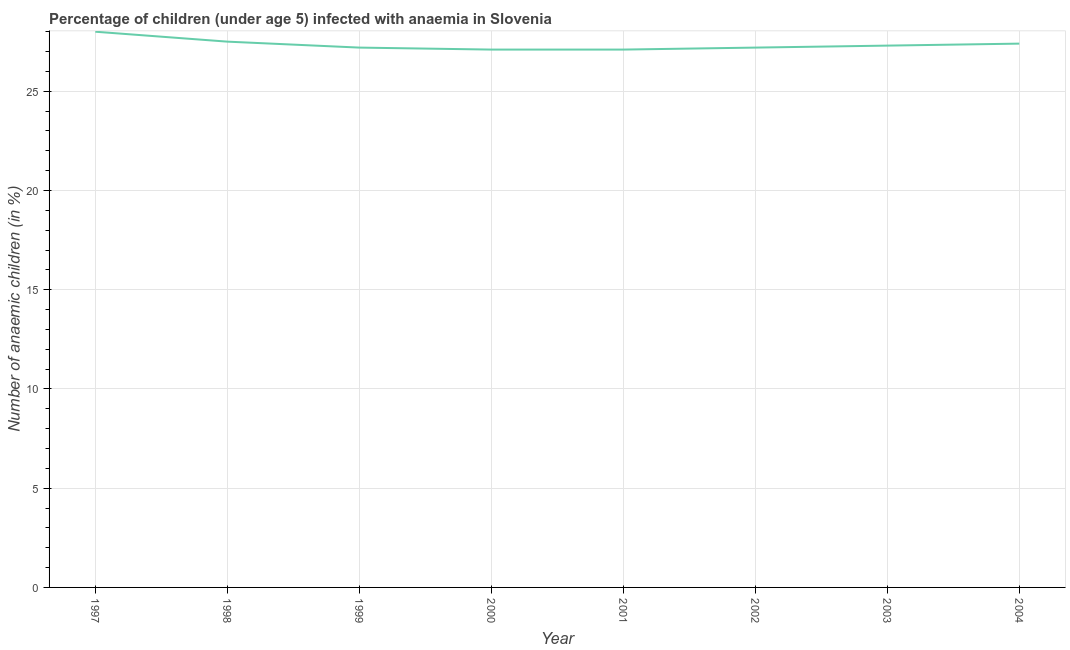What is the number of anaemic children in 1999?
Your answer should be compact. 27.2. Across all years, what is the maximum number of anaemic children?
Your answer should be very brief. 28. Across all years, what is the minimum number of anaemic children?
Your answer should be very brief. 27.1. What is the sum of the number of anaemic children?
Offer a terse response. 218.8. What is the average number of anaemic children per year?
Your response must be concise. 27.35. What is the median number of anaemic children?
Your answer should be very brief. 27.25. In how many years, is the number of anaemic children greater than 25 %?
Offer a very short reply. 8. What is the ratio of the number of anaemic children in 1997 to that in 1998?
Your answer should be compact. 1.02. Is the number of anaemic children in 1998 less than that in 2004?
Ensure brevity in your answer.  No. Is the difference between the number of anaemic children in 1997 and 2004 greater than the difference between any two years?
Make the answer very short. No. What is the difference between the highest and the lowest number of anaemic children?
Offer a very short reply. 0.9. In how many years, is the number of anaemic children greater than the average number of anaemic children taken over all years?
Offer a terse response. 3. How many lines are there?
Your answer should be compact. 1. What is the difference between two consecutive major ticks on the Y-axis?
Your answer should be compact. 5. Does the graph contain grids?
Your response must be concise. Yes. What is the title of the graph?
Give a very brief answer. Percentage of children (under age 5) infected with anaemia in Slovenia. What is the label or title of the X-axis?
Give a very brief answer. Year. What is the label or title of the Y-axis?
Provide a succinct answer. Number of anaemic children (in %). What is the Number of anaemic children (in %) in 1997?
Provide a succinct answer. 28. What is the Number of anaemic children (in %) of 1999?
Offer a terse response. 27.2. What is the Number of anaemic children (in %) in 2000?
Provide a short and direct response. 27.1. What is the Number of anaemic children (in %) in 2001?
Your answer should be compact. 27.1. What is the Number of anaemic children (in %) of 2002?
Give a very brief answer. 27.2. What is the Number of anaemic children (in %) in 2003?
Your answer should be very brief. 27.3. What is the Number of anaemic children (in %) in 2004?
Offer a terse response. 27.4. What is the difference between the Number of anaemic children (in %) in 1997 and 1998?
Provide a short and direct response. 0.5. What is the difference between the Number of anaemic children (in %) in 1997 and 1999?
Offer a terse response. 0.8. What is the difference between the Number of anaemic children (in %) in 1997 and 2000?
Offer a very short reply. 0.9. What is the difference between the Number of anaemic children (in %) in 1997 and 2001?
Ensure brevity in your answer.  0.9. What is the difference between the Number of anaemic children (in %) in 1997 and 2003?
Give a very brief answer. 0.7. What is the difference between the Number of anaemic children (in %) in 1998 and 2000?
Provide a succinct answer. 0.4. What is the difference between the Number of anaemic children (in %) in 1998 and 2002?
Make the answer very short. 0.3. What is the difference between the Number of anaemic children (in %) in 1999 and 2002?
Offer a terse response. 0. What is the difference between the Number of anaemic children (in %) in 1999 and 2004?
Make the answer very short. -0.2. What is the difference between the Number of anaemic children (in %) in 2000 and 2001?
Offer a terse response. 0. What is the difference between the Number of anaemic children (in %) in 2000 and 2003?
Give a very brief answer. -0.2. What is the difference between the Number of anaemic children (in %) in 2000 and 2004?
Give a very brief answer. -0.3. What is the difference between the Number of anaemic children (in %) in 2001 and 2002?
Your response must be concise. -0.1. What is the difference between the Number of anaemic children (in %) in 2002 and 2003?
Keep it short and to the point. -0.1. What is the difference between the Number of anaemic children (in %) in 2003 and 2004?
Your answer should be compact. -0.1. What is the ratio of the Number of anaemic children (in %) in 1997 to that in 2000?
Offer a terse response. 1.03. What is the ratio of the Number of anaemic children (in %) in 1997 to that in 2001?
Your response must be concise. 1.03. What is the ratio of the Number of anaemic children (in %) in 1997 to that in 2003?
Provide a succinct answer. 1.03. What is the ratio of the Number of anaemic children (in %) in 1998 to that in 1999?
Your answer should be very brief. 1.01. What is the ratio of the Number of anaemic children (in %) in 1998 to that in 2001?
Keep it short and to the point. 1.01. What is the ratio of the Number of anaemic children (in %) in 1998 to that in 2002?
Make the answer very short. 1.01. What is the ratio of the Number of anaemic children (in %) in 1999 to that in 2000?
Keep it short and to the point. 1. What is the ratio of the Number of anaemic children (in %) in 1999 to that in 2002?
Provide a short and direct response. 1. What is the ratio of the Number of anaemic children (in %) in 1999 to that in 2004?
Make the answer very short. 0.99. What is the ratio of the Number of anaemic children (in %) in 2000 to that in 2002?
Keep it short and to the point. 1. What is the ratio of the Number of anaemic children (in %) in 2000 to that in 2003?
Your answer should be compact. 0.99. What is the ratio of the Number of anaemic children (in %) in 2001 to that in 2003?
Keep it short and to the point. 0.99. What is the ratio of the Number of anaemic children (in %) in 2001 to that in 2004?
Offer a terse response. 0.99. What is the ratio of the Number of anaemic children (in %) in 2002 to that in 2004?
Ensure brevity in your answer.  0.99. 